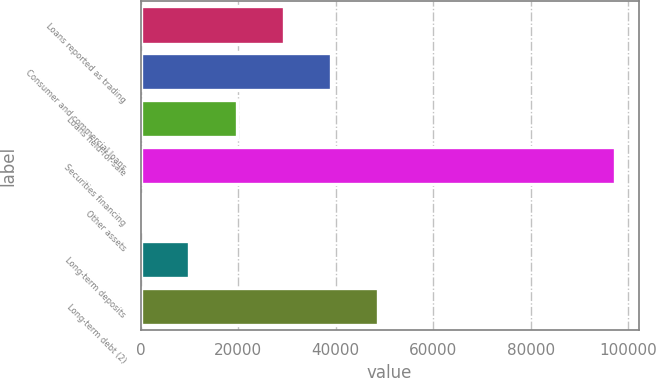<chart> <loc_0><loc_0><loc_500><loc_500><bar_chart><fcel>Loans reported as trading<fcel>Consumer and commercial loans<fcel>Loans held-for-sale<fcel>Securities financing<fcel>Other assets<fcel>Long-term deposits<fcel>Long-term debt (2)<nl><fcel>29359.2<fcel>39055.6<fcel>19662.8<fcel>97234<fcel>270<fcel>9966.4<fcel>48752<nl></chart> 